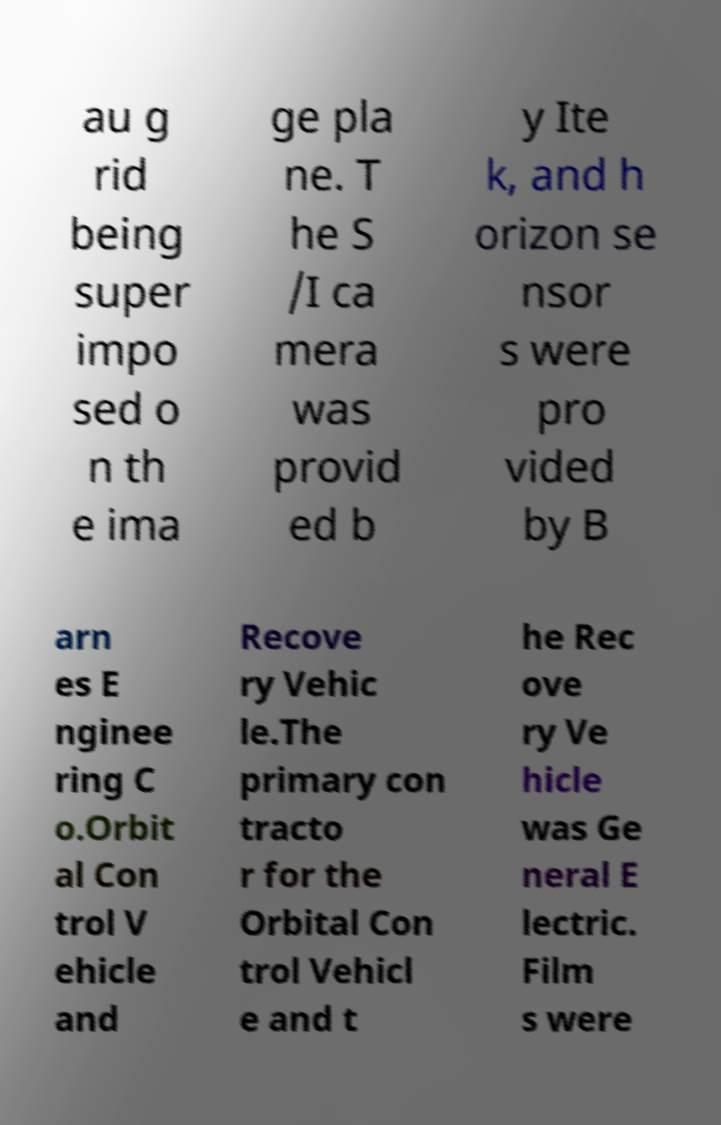There's text embedded in this image that I need extracted. Can you transcribe it verbatim? au g rid being super impo sed o n th e ima ge pla ne. T he S /I ca mera was provid ed b y Ite k, and h orizon se nsor s were pro vided by B arn es E nginee ring C o.Orbit al Con trol V ehicle and Recove ry Vehic le.The primary con tracto r for the Orbital Con trol Vehicl e and t he Rec ove ry Ve hicle was Ge neral E lectric. Film s were 